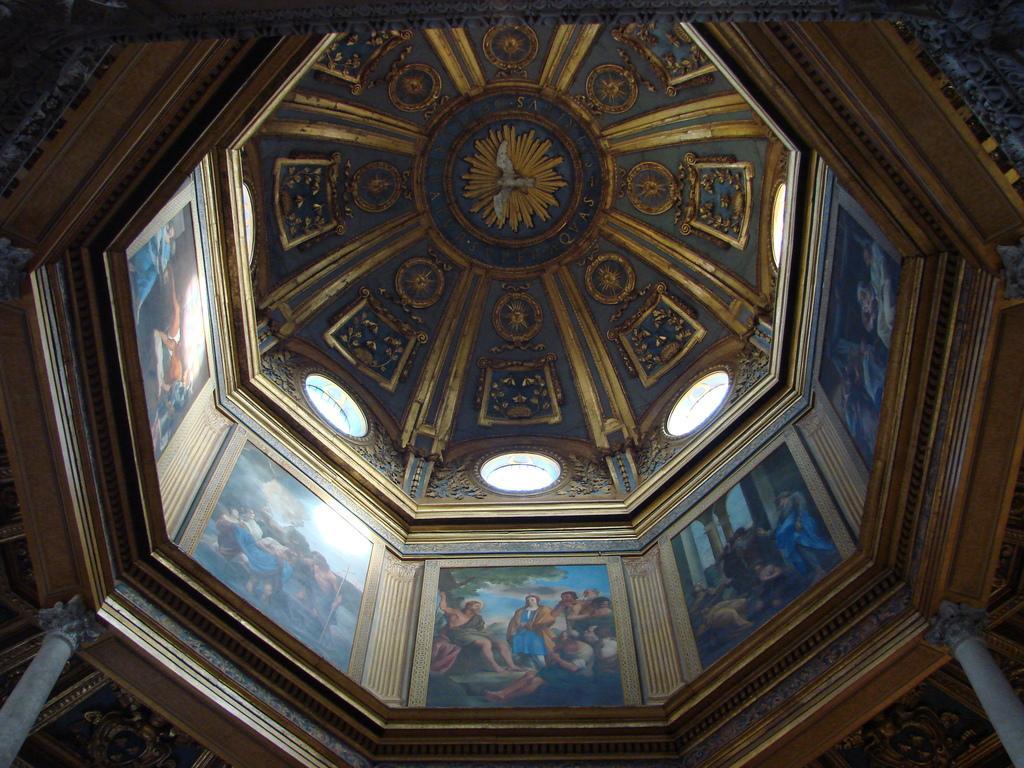Please provide a concise description of this image. In this image we can see an interior of a building. We can see paintings and decorations on the wall. Also there are pillars. 